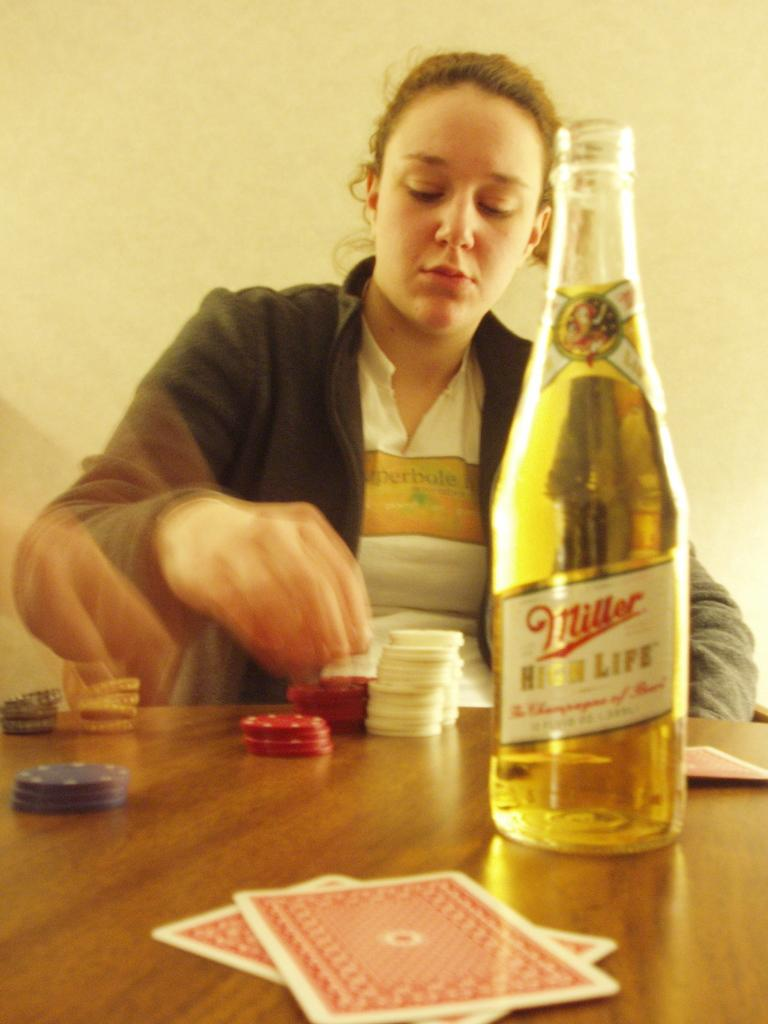<image>
Create a compact narrative representing the image presented. A person is stacking poker chips behind a bottle of Miller beer. 